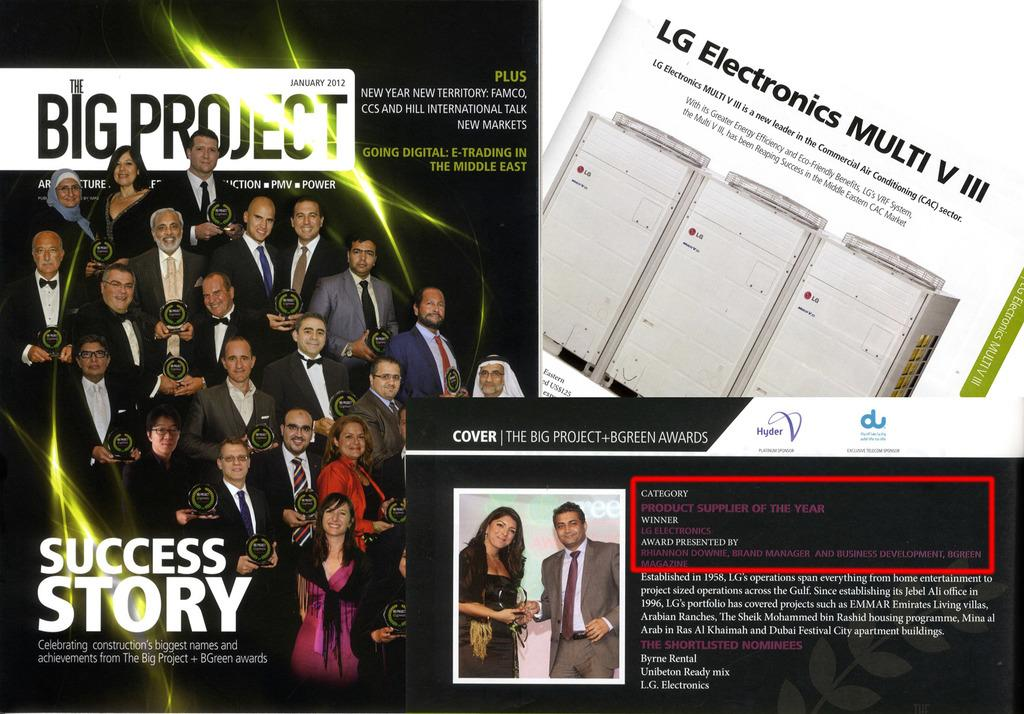<image>
Share a concise interpretation of the image provided. A page saying Big Project Success Story and shows an LG book. 